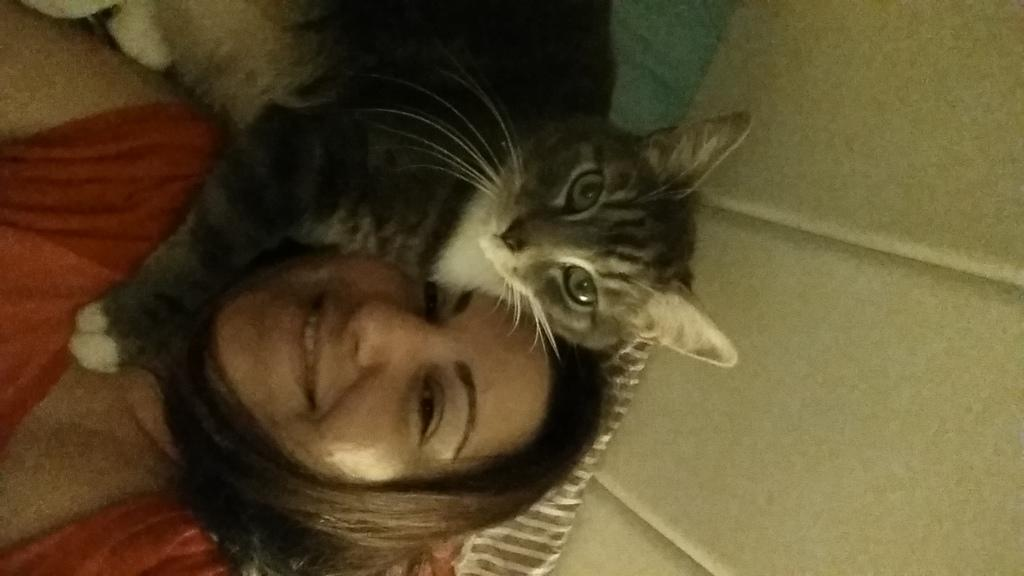Who is present in the image? There is a woman in the image. What is the woman doing in the image? The woman is smiling in the image. What other living creature is present in the image? There is a cat in the image. What is the background of the image? There is a wall in the image. What type of fang can be seen in the image? There is no fang present in the image. How many trees are visible in the image? There are no trees visible in the image. 